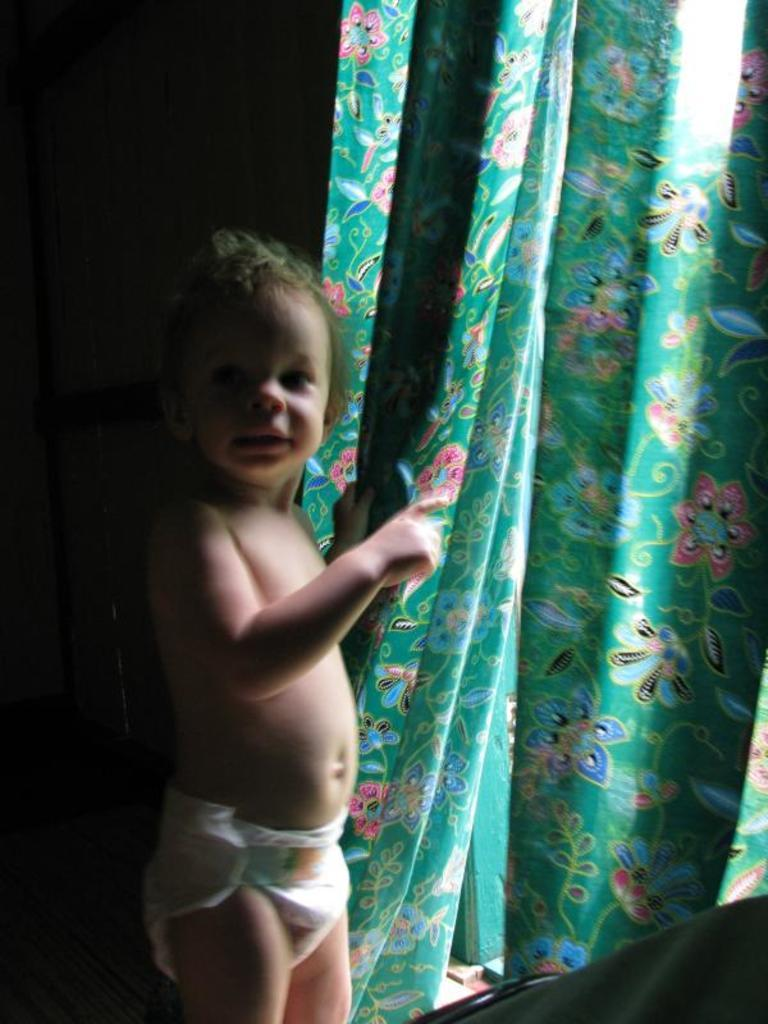What is the main subject of the image? There is a child in the image. What is the child doing in the image? The child is standing and holding a curtain. What is in front of the child? There is an object in front of the child. How would you describe the background of the image? The background of the image is dark. What type of stitch is the child attempting to sew in the image? There is no indication of sewing or stitching in the image; the child is holding a curtain. What type of collar is visible on the child in the image? There is no collar visible on the child in the image; the child is wearing a shirt or dress, but no collar is mentioned in the provided facts. 